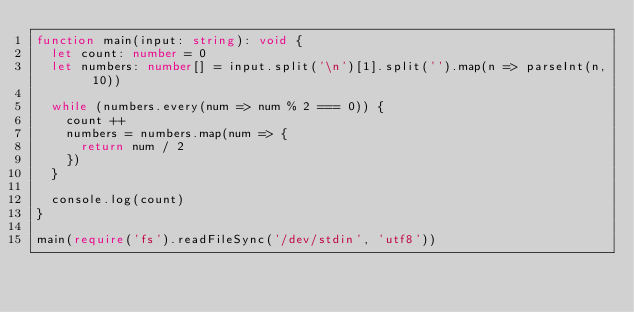Convert code to text. <code><loc_0><loc_0><loc_500><loc_500><_TypeScript_>function main(input: string): void {
  let count: number = 0
  let numbers: number[] = input.split('\n')[1].split('').map(n => parseInt(n, 10))

  while (numbers.every(num => num % 2 === 0)) {
    count ++
    numbers = numbers.map(num => {
      return num / 2
    })
  }

  console.log(count)
}

main(require('fs').readFileSync('/dev/stdin', 'utf8'))</code> 